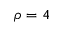Convert formula to latex. <formula><loc_0><loc_0><loc_500><loc_500>\rho = 4</formula> 